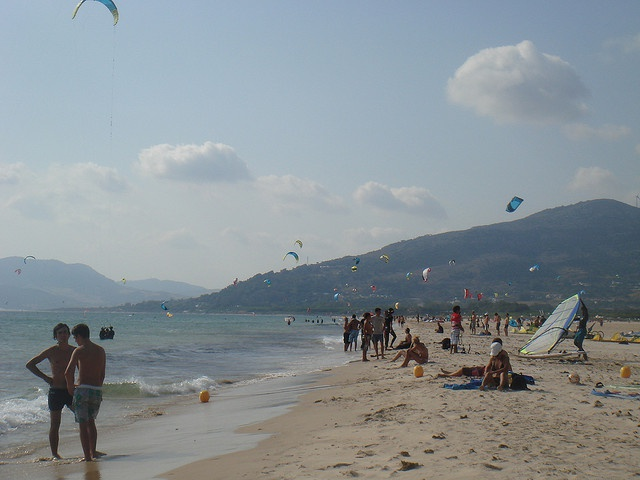Describe the objects in this image and their specific colors. I can see people in lightblue, black, and gray tones, people in lightblue, black, and gray tones, kite in lightblue, gray, darkgray, and blue tones, people in lightblue, black, gray, and blue tones, and people in lightblue, black, maroon, and gray tones in this image. 